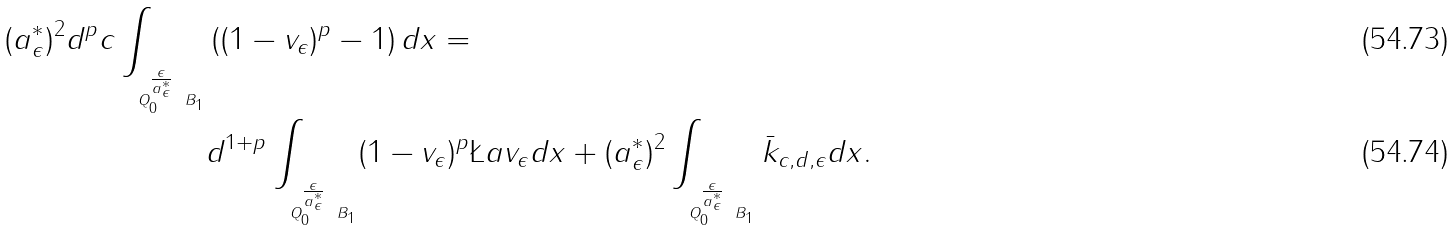<formula> <loc_0><loc_0><loc_500><loc_500>( a ^ { \ast } _ { \epsilon } ) ^ { 2 } d ^ { p } c \int _ { _ { Q ^ { ^ { \frac { \epsilon } { a ^ { \ast } _ { \epsilon } } } } _ { 0 } \ B _ { 1 } } } & \left ( ( 1 - v _ { \epsilon } ) ^ { p } - 1 \right ) d x = \\ & d ^ { 1 + p } \int _ { _ { Q ^ { ^ { \frac { \epsilon } { a ^ { \ast } _ { \epsilon } } } } _ { 0 } \ B _ { 1 } } } ( 1 - v _ { \epsilon } ) ^ { p } \L a v _ { \epsilon } d x + ( a ^ { \ast } _ { \epsilon } ) ^ { 2 } \int _ { _ { Q ^ { ^ { \frac { \epsilon } { a ^ { \ast } _ { \epsilon } } } } _ { 0 } \ B _ { 1 } } } \bar { k } _ { c , d , \epsilon } d x .</formula> 